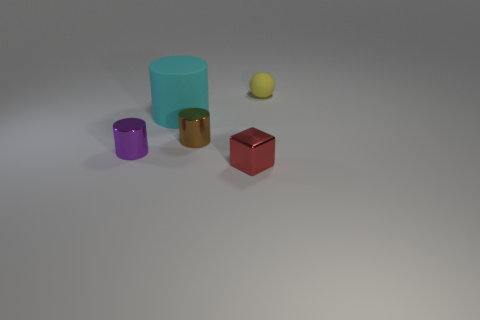Add 2 small metallic objects. How many objects exist? 7 Subtract all small metal cylinders. How many cylinders are left? 1 Subtract 1 cubes. How many cubes are left? 0 Subtract all blocks. How many objects are left? 4 Add 4 tiny brown things. How many tiny brown things are left? 5 Add 1 small brown shiny objects. How many small brown shiny objects exist? 2 Subtract 0 yellow cylinders. How many objects are left? 5 Subtract all yellow cylinders. Subtract all purple spheres. How many cylinders are left? 3 Subtract all yellow matte cubes. Subtract all large rubber objects. How many objects are left? 4 